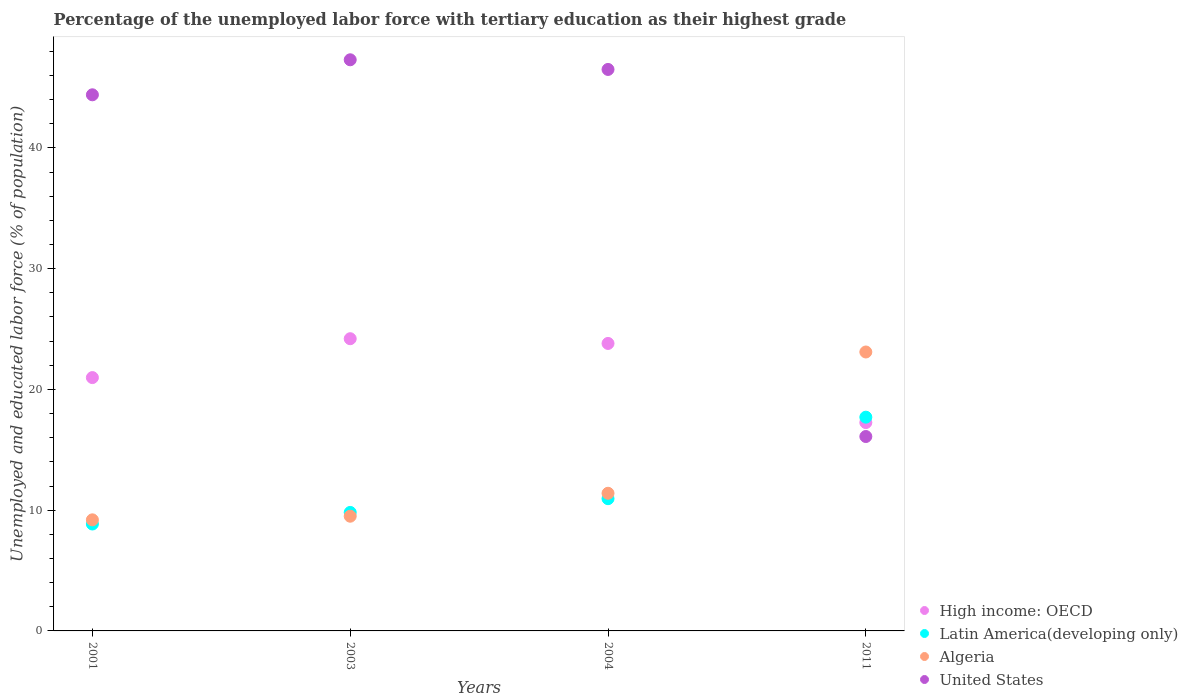How many different coloured dotlines are there?
Your answer should be compact. 4. Is the number of dotlines equal to the number of legend labels?
Offer a very short reply. Yes. Across all years, what is the maximum percentage of the unemployed labor force with tertiary education in Latin America(developing only)?
Provide a succinct answer. 17.7. Across all years, what is the minimum percentage of the unemployed labor force with tertiary education in Latin America(developing only)?
Offer a very short reply. 8.85. In which year was the percentage of the unemployed labor force with tertiary education in United States maximum?
Your response must be concise. 2003. In which year was the percentage of the unemployed labor force with tertiary education in Latin America(developing only) minimum?
Offer a terse response. 2001. What is the total percentage of the unemployed labor force with tertiary education in Latin America(developing only) in the graph?
Offer a terse response. 47.32. What is the difference between the percentage of the unemployed labor force with tertiary education in Latin America(developing only) in 2003 and that in 2004?
Your answer should be compact. -1.14. What is the difference between the percentage of the unemployed labor force with tertiary education in High income: OECD in 2003 and the percentage of the unemployed labor force with tertiary education in United States in 2001?
Your answer should be compact. -20.2. What is the average percentage of the unemployed labor force with tertiary education in Latin America(developing only) per year?
Your answer should be very brief. 11.83. In the year 2003, what is the difference between the percentage of the unemployed labor force with tertiary education in United States and percentage of the unemployed labor force with tertiary education in Latin America(developing only)?
Make the answer very short. 37.49. In how many years, is the percentage of the unemployed labor force with tertiary education in Algeria greater than 4 %?
Keep it short and to the point. 4. What is the ratio of the percentage of the unemployed labor force with tertiary education in United States in 2003 to that in 2004?
Give a very brief answer. 1.02. Is the percentage of the unemployed labor force with tertiary education in High income: OECD in 2001 less than that in 2011?
Offer a terse response. No. Is the difference between the percentage of the unemployed labor force with tertiary education in United States in 2001 and 2003 greater than the difference between the percentage of the unemployed labor force with tertiary education in Latin America(developing only) in 2001 and 2003?
Give a very brief answer. No. What is the difference between the highest and the second highest percentage of the unemployed labor force with tertiary education in United States?
Your response must be concise. 0.8. What is the difference between the highest and the lowest percentage of the unemployed labor force with tertiary education in Algeria?
Ensure brevity in your answer.  13.9. Is the sum of the percentage of the unemployed labor force with tertiary education in Algeria in 2004 and 2011 greater than the maximum percentage of the unemployed labor force with tertiary education in United States across all years?
Your response must be concise. No. Does the percentage of the unemployed labor force with tertiary education in High income: OECD monotonically increase over the years?
Provide a short and direct response. No. How many dotlines are there?
Your answer should be very brief. 4. What is the difference between two consecutive major ticks on the Y-axis?
Your answer should be compact. 10. Does the graph contain grids?
Make the answer very short. No. Where does the legend appear in the graph?
Make the answer very short. Bottom right. What is the title of the graph?
Give a very brief answer. Percentage of the unemployed labor force with tertiary education as their highest grade. Does "Tajikistan" appear as one of the legend labels in the graph?
Make the answer very short. No. What is the label or title of the Y-axis?
Offer a very short reply. Unemployed and educated labor force (% of population). What is the Unemployed and educated labor force (% of population) in High income: OECD in 2001?
Offer a very short reply. 20.98. What is the Unemployed and educated labor force (% of population) in Latin America(developing only) in 2001?
Provide a succinct answer. 8.85. What is the Unemployed and educated labor force (% of population) of Algeria in 2001?
Your answer should be compact. 9.2. What is the Unemployed and educated labor force (% of population) in United States in 2001?
Offer a terse response. 44.4. What is the Unemployed and educated labor force (% of population) of High income: OECD in 2003?
Make the answer very short. 24.2. What is the Unemployed and educated labor force (% of population) of Latin America(developing only) in 2003?
Offer a terse response. 9.81. What is the Unemployed and educated labor force (% of population) of Algeria in 2003?
Provide a succinct answer. 9.5. What is the Unemployed and educated labor force (% of population) in United States in 2003?
Your answer should be very brief. 47.3. What is the Unemployed and educated labor force (% of population) in High income: OECD in 2004?
Provide a short and direct response. 23.81. What is the Unemployed and educated labor force (% of population) in Latin America(developing only) in 2004?
Keep it short and to the point. 10.95. What is the Unemployed and educated labor force (% of population) in Algeria in 2004?
Offer a terse response. 11.4. What is the Unemployed and educated labor force (% of population) in United States in 2004?
Keep it short and to the point. 46.5. What is the Unemployed and educated labor force (% of population) of High income: OECD in 2011?
Your answer should be very brief. 17.26. What is the Unemployed and educated labor force (% of population) in Latin America(developing only) in 2011?
Provide a succinct answer. 17.7. What is the Unemployed and educated labor force (% of population) of Algeria in 2011?
Provide a short and direct response. 23.1. What is the Unemployed and educated labor force (% of population) of United States in 2011?
Your answer should be very brief. 16.1. Across all years, what is the maximum Unemployed and educated labor force (% of population) in High income: OECD?
Offer a terse response. 24.2. Across all years, what is the maximum Unemployed and educated labor force (% of population) in Latin America(developing only)?
Your response must be concise. 17.7. Across all years, what is the maximum Unemployed and educated labor force (% of population) in Algeria?
Offer a terse response. 23.1. Across all years, what is the maximum Unemployed and educated labor force (% of population) of United States?
Ensure brevity in your answer.  47.3. Across all years, what is the minimum Unemployed and educated labor force (% of population) of High income: OECD?
Provide a succinct answer. 17.26. Across all years, what is the minimum Unemployed and educated labor force (% of population) in Latin America(developing only)?
Provide a succinct answer. 8.85. Across all years, what is the minimum Unemployed and educated labor force (% of population) in Algeria?
Ensure brevity in your answer.  9.2. Across all years, what is the minimum Unemployed and educated labor force (% of population) in United States?
Provide a succinct answer. 16.1. What is the total Unemployed and educated labor force (% of population) in High income: OECD in the graph?
Your answer should be very brief. 86.24. What is the total Unemployed and educated labor force (% of population) in Latin America(developing only) in the graph?
Keep it short and to the point. 47.32. What is the total Unemployed and educated labor force (% of population) in Algeria in the graph?
Give a very brief answer. 53.2. What is the total Unemployed and educated labor force (% of population) of United States in the graph?
Provide a succinct answer. 154.3. What is the difference between the Unemployed and educated labor force (% of population) of High income: OECD in 2001 and that in 2003?
Provide a succinct answer. -3.22. What is the difference between the Unemployed and educated labor force (% of population) of Latin America(developing only) in 2001 and that in 2003?
Give a very brief answer. -0.96. What is the difference between the Unemployed and educated labor force (% of population) of Algeria in 2001 and that in 2003?
Your answer should be very brief. -0.3. What is the difference between the Unemployed and educated labor force (% of population) of High income: OECD in 2001 and that in 2004?
Provide a short and direct response. -2.83. What is the difference between the Unemployed and educated labor force (% of population) in Latin America(developing only) in 2001 and that in 2004?
Keep it short and to the point. -2.1. What is the difference between the Unemployed and educated labor force (% of population) in Algeria in 2001 and that in 2004?
Make the answer very short. -2.2. What is the difference between the Unemployed and educated labor force (% of population) of United States in 2001 and that in 2004?
Offer a very short reply. -2.1. What is the difference between the Unemployed and educated labor force (% of population) in High income: OECD in 2001 and that in 2011?
Ensure brevity in your answer.  3.72. What is the difference between the Unemployed and educated labor force (% of population) of Latin America(developing only) in 2001 and that in 2011?
Provide a succinct answer. -8.85. What is the difference between the Unemployed and educated labor force (% of population) in United States in 2001 and that in 2011?
Your response must be concise. 28.3. What is the difference between the Unemployed and educated labor force (% of population) in High income: OECD in 2003 and that in 2004?
Your answer should be very brief. 0.39. What is the difference between the Unemployed and educated labor force (% of population) of Latin America(developing only) in 2003 and that in 2004?
Your answer should be very brief. -1.14. What is the difference between the Unemployed and educated labor force (% of population) of Algeria in 2003 and that in 2004?
Your answer should be compact. -1.9. What is the difference between the Unemployed and educated labor force (% of population) in High income: OECD in 2003 and that in 2011?
Provide a short and direct response. 6.94. What is the difference between the Unemployed and educated labor force (% of population) of Latin America(developing only) in 2003 and that in 2011?
Your response must be concise. -7.89. What is the difference between the Unemployed and educated labor force (% of population) in Algeria in 2003 and that in 2011?
Offer a terse response. -13.6. What is the difference between the Unemployed and educated labor force (% of population) of United States in 2003 and that in 2011?
Your answer should be compact. 31.2. What is the difference between the Unemployed and educated labor force (% of population) in High income: OECD in 2004 and that in 2011?
Ensure brevity in your answer.  6.55. What is the difference between the Unemployed and educated labor force (% of population) of Latin America(developing only) in 2004 and that in 2011?
Your answer should be very brief. -6.75. What is the difference between the Unemployed and educated labor force (% of population) in Algeria in 2004 and that in 2011?
Your response must be concise. -11.7. What is the difference between the Unemployed and educated labor force (% of population) in United States in 2004 and that in 2011?
Provide a short and direct response. 30.4. What is the difference between the Unemployed and educated labor force (% of population) of High income: OECD in 2001 and the Unemployed and educated labor force (% of population) of Latin America(developing only) in 2003?
Offer a terse response. 11.17. What is the difference between the Unemployed and educated labor force (% of population) in High income: OECD in 2001 and the Unemployed and educated labor force (% of population) in Algeria in 2003?
Provide a succinct answer. 11.48. What is the difference between the Unemployed and educated labor force (% of population) in High income: OECD in 2001 and the Unemployed and educated labor force (% of population) in United States in 2003?
Ensure brevity in your answer.  -26.32. What is the difference between the Unemployed and educated labor force (% of population) in Latin America(developing only) in 2001 and the Unemployed and educated labor force (% of population) in Algeria in 2003?
Your answer should be compact. -0.65. What is the difference between the Unemployed and educated labor force (% of population) of Latin America(developing only) in 2001 and the Unemployed and educated labor force (% of population) of United States in 2003?
Give a very brief answer. -38.45. What is the difference between the Unemployed and educated labor force (% of population) in Algeria in 2001 and the Unemployed and educated labor force (% of population) in United States in 2003?
Offer a very short reply. -38.1. What is the difference between the Unemployed and educated labor force (% of population) in High income: OECD in 2001 and the Unemployed and educated labor force (% of population) in Latin America(developing only) in 2004?
Provide a succinct answer. 10.03. What is the difference between the Unemployed and educated labor force (% of population) in High income: OECD in 2001 and the Unemployed and educated labor force (% of population) in Algeria in 2004?
Offer a terse response. 9.58. What is the difference between the Unemployed and educated labor force (% of population) of High income: OECD in 2001 and the Unemployed and educated labor force (% of population) of United States in 2004?
Provide a short and direct response. -25.52. What is the difference between the Unemployed and educated labor force (% of population) in Latin America(developing only) in 2001 and the Unemployed and educated labor force (% of population) in Algeria in 2004?
Ensure brevity in your answer.  -2.55. What is the difference between the Unemployed and educated labor force (% of population) of Latin America(developing only) in 2001 and the Unemployed and educated labor force (% of population) of United States in 2004?
Make the answer very short. -37.65. What is the difference between the Unemployed and educated labor force (% of population) in Algeria in 2001 and the Unemployed and educated labor force (% of population) in United States in 2004?
Your answer should be compact. -37.3. What is the difference between the Unemployed and educated labor force (% of population) in High income: OECD in 2001 and the Unemployed and educated labor force (% of population) in Latin America(developing only) in 2011?
Your answer should be very brief. 3.28. What is the difference between the Unemployed and educated labor force (% of population) of High income: OECD in 2001 and the Unemployed and educated labor force (% of population) of Algeria in 2011?
Make the answer very short. -2.12. What is the difference between the Unemployed and educated labor force (% of population) in High income: OECD in 2001 and the Unemployed and educated labor force (% of population) in United States in 2011?
Make the answer very short. 4.88. What is the difference between the Unemployed and educated labor force (% of population) of Latin America(developing only) in 2001 and the Unemployed and educated labor force (% of population) of Algeria in 2011?
Provide a short and direct response. -14.25. What is the difference between the Unemployed and educated labor force (% of population) of Latin America(developing only) in 2001 and the Unemployed and educated labor force (% of population) of United States in 2011?
Ensure brevity in your answer.  -7.25. What is the difference between the Unemployed and educated labor force (% of population) of High income: OECD in 2003 and the Unemployed and educated labor force (% of population) of Latin America(developing only) in 2004?
Ensure brevity in your answer.  13.25. What is the difference between the Unemployed and educated labor force (% of population) in High income: OECD in 2003 and the Unemployed and educated labor force (% of population) in Algeria in 2004?
Offer a very short reply. 12.8. What is the difference between the Unemployed and educated labor force (% of population) in High income: OECD in 2003 and the Unemployed and educated labor force (% of population) in United States in 2004?
Your answer should be compact. -22.3. What is the difference between the Unemployed and educated labor force (% of population) in Latin America(developing only) in 2003 and the Unemployed and educated labor force (% of population) in Algeria in 2004?
Provide a short and direct response. -1.59. What is the difference between the Unemployed and educated labor force (% of population) of Latin America(developing only) in 2003 and the Unemployed and educated labor force (% of population) of United States in 2004?
Ensure brevity in your answer.  -36.69. What is the difference between the Unemployed and educated labor force (% of population) of Algeria in 2003 and the Unemployed and educated labor force (% of population) of United States in 2004?
Your answer should be compact. -37. What is the difference between the Unemployed and educated labor force (% of population) of High income: OECD in 2003 and the Unemployed and educated labor force (% of population) of Latin America(developing only) in 2011?
Give a very brief answer. 6.5. What is the difference between the Unemployed and educated labor force (% of population) of High income: OECD in 2003 and the Unemployed and educated labor force (% of population) of United States in 2011?
Your answer should be very brief. 8.1. What is the difference between the Unemployed and educated labor force (% of population) in Latin America(developing only) in 2003 and the Unemployed and educated labor force (% of population) in Algeria in 2011?
Your response must be concise. -13.29. What is the difference between the Unemployed and educated labor force (% of population) in Latin America(developing only) in 2003 and the Unemployed and educated labor force (% of population) in United States in 2011?
Provide a short and direct response. -6.29. What is the difference between the Unemployed and educated labor force (% of population) of High income: OECD in 2004 and the Unemployed and educated labor force (% of population) of Latin America(developing only) in 2011?
Keep it short and to the point. 6.11. What is the difference between the Unemployed and educated labor force (% of population) of High income: OECD in 2004 and the Unemployed and educated labor force (% of population) of Algeria in 2011?
Your answer should be very brief. 0.71. What is the difference between the Unemployed and educated labor force (% of population) of High income: OECD in 2004 and the Unemployed and educated labor force (% of population) of United States in 2011?
Provide a succinct answer. 7.71. What is the difference between the Unemployed and educated labor force (% of population) in Latin America(developing only) in 2004 and the Unemployed and educated labor force (% of population) in Algeria in 2011?
Your response must be concise. -12.15. What is the difference between the Unemployed and educated labor force (% of population) of Latin America(developing only) in 2004 and the Unemployed and educated labor force (% of population) of United States in 2011?
Your answer should be compact. -5.15. What is the average Unemployed and educated labor force (% of population) in High income: OECD per year?
Your response must be concise. 21.56. What is the average Unemployed and educated labor force (% of population) in Latin America(developing only) per year?
Your answer should be very brief. 11.83. What is the average Unemployed and educated labor force (% of population) in United States per year?
Keep it short and to the point. 38.58. In the year 2001, what is the difference between the Unemployed and educated labor force (% of population) of High income: OECD and Unemployed and educated labor force (% of population) of Latin America(developing only)?
Offer a very short reply. 12.13. In the year 2001, what is the difference between the Unemployed and educated labor force (% of population) of High income: OECD and Unemployed and educated labor force (% of population) of Algeria?
Keep it short and to the point. 11.78. In the year 2001, what is the difference between the Unemployed and educated labor force (% of population) in High income: OECD and Unemployed and educated labor force (% of population) in United States?
Make the answer very short. -23.42. In the year 2001, what is the difference between the Unemployed and educated labor force (% of population) in Latin America(developing only) and Unemployed and educated labor force (% of population) in Algeria?
Make the answer very short. -0.35. In the year 2001, what is the difference between the Unemployed and educated labor force (% of population) in Latin America(developing only) and Unemployed and educated labor force (% of population) in United States?
Provide a succinct answer. -35.55. In the year 2001, what is the difference between the Unemployed and educated labor force (% of population) in Algeria and Unemployed and educated labor force (% of population) in United States?
Your answer should be compact. -35.2. In the year 2003, what is the difference between the Unemployed and educated labor force (% of population) in High income: OECD and Unemployed and educated labor force (% of population) in Latin America(developing only)?
Your answer should be very brief. 14.39. In the year 2003, what is the difference between the Unemployed and educated labor force (% of population) of High income: OECD and Unemployed and educated labor force (% of population) of Algeria?
Make the answer very short. 14.7. In the year 2003, what is the difference between the Unemployed and educated labor force (% of population) of High income: OECD and Unemployed and educated labor force (% of population) of United States?
Give a very brief answer. -23.1. In the year 2003, what is the difference between the Unemployed and educated labor force (% of population) in Latin America(developing only) and Unemployed and educated labor force (% of population) in Algeria?
Provide a short and direct response. 0.31. In the year 2003, what is the difference between the Unemployed and educated labor force (% of population) in Latin America(developing only) and Unemployed and educated labor force (% of population) in United States?
Provide a short and direct response. -37.49. In the year 2003, what is the difference between the Unemployed and educated labor force (% of population) in Algeria and Unemployed and educated labor force (% of population) in United States?
Offer a very short reply. -37.8. In the year 2004, what is the difference between the Unemployed and educated labor force (% of population) in High income: OECD and Unemployed and educated labor force (% of population) in Latin America(developing only)?
Provide a succinct answer. 12.86. In the year 2004, what is the difference between the Unemployed and educated labor force (% of population) in High income: OECD and Unemployed and educated labor force (% of population) in Algeria?
Give a very brief answer. 12.41. In the year 2004, what is the difference between the Unemployed and educated labor force (% of population) of High income: OECD and Unemployed and educated labor force (% of population) of United States?
Provide a short and direct response. -22.69. In the year 2004, what is the difference between the Unemployed and educated labor force (% of population) in Latin America(developing only) and Unemployed and educated labor force (% of population) in Algeria?
Your response must be concise. -0.45. In the year 2004, what is the difference between the Unemployed and educated labor force (% of population) in Latin America(developing only) and Unemployed and educated labor force (% of population) in United States?
Make the answer very short. -35.55. In the year 2004, what is the difference between the Unemployed and educated labor force (% of population) of Algeria and Unemployed and educated labor force (% of population) of United States?
Keep it short and to the point. -35.1. In the year 2011, what is the difference between the Unemployed and educated labor force (% of population) in High income: OECD and Unemployed and educated labor force (% of population) in Latin America(developing only)?
Offer a terse response. -0.45. In the year 2011, what is the difference between the Unemployed and educated labor force (% of population) in High income: OECD and Unemployed and educated labor force (% of population) in Algeria?
Ensure brevity in your answer.  -5.84. In the year 2011, what is the difference between the Unemployed and educated labor force (% of population) of High income: OECD and Unemployed and educated labor force (% of population) of United States?
Your response must be concise. 1.16. In the year 2011, what is the difference between the Unemployed and educated labor force (% of population) of Latin America(developing only) and Unemployed and educated labor force (% of population) of Algeria?
Give a very brief answer. -5.4. In the year 2011, what is the difference between the Unemployed and educated labor force (% of population) of Latin America(developing only) and Unemployed and educated labor force (% of population) of United States?
Ensure brevity in your answer.  1.6. In the year 2011, what is the difference between the Unemployed and educated labor force (% of population) in Algeria and Unemployed and educated labor force (% of population) in United States?
Ensure brevity in your answer.  7. What is the ratio of the Unemployed and educated labor force (% of population) of High income: OECD in 2001 to that in 2003?
Keep it short and to the point. 0.87. What is the ratio of the Unemployed and educated labor force (% of population) of Latin America(developing only) in 2001 to that in 2003?
Provide a succinct answer. 0.9. What is the ratio of the Unemployed and educated labor force (% of population) of Algeria in 2001 to that in 2003?
Ensure brevity in your answer.  0.97. What is the ratio of the Unemployed and educated labor force (% of population) of United States in 2001 to that in 2003?
Your answer should be compact. 0.94. What is the ratio of the Unemployed and educated labor force (% of population) of High income: OECD in 2001 to that in 2004?
Make the answer very short. 0.88. What is the ratio of the Unemployed and educated labor force (% of population) of Latin America(developing only) in 2001 to that in 2004?
Offer a terse response. 0.81. What is the ratio of the Unemployed and educated labor force (% of population) in Algeria in 2001 to that in 2004?
Your answer should be compact. 0.81. What is the ratio of the Unemployed and educated labor force (% of population) of United States in 2001 to that in 2004?
Give a very brief answer. 0.95. What is the ratio of the Unemployed and educated labor force (% of population) of High income: OECD in 2001 to that in 2011?
Provide a succinct answer. 1.22. What is the ratio of the Unemployed and educated labor force (% of population) of Latin America(developing only) in 2001 to that in 2011?
Offer a terse response. 0.5. What is the ratio of the Unemployed and educated labor force (% of population) in Algeria in 2001 to that in 2011?
Keep it short and to the point. 0.4. What is the ratio of the Unemployed and educated labor force (% of population) of United States in 2001 to that in 2011?
Ensure brevity in your answer.  2.76. What is the ratio of the Unemployed and educated labor force (% of population) of High income: OECD in 2003 to that in 2004?
Ensure brevity in your answer.  1.02. What is the ratio of the Unemployed and educated labor force (% of population) in Latin America(developing only) in 2003 to that in 2004?
Your response must be concise. 0.9. What is the ratio of the Unemployed and educated labor force (% of population) in United States in 2003 to that in 2004?
Give a very brief answer. 1.02. What is the ratio of the Unemployed and educated labor force (% of population) of High income: OECD in 2003 to that in 2011?
Make the answer very short. 1.4. What is the ratio of the Unemployed and educated labor force (% of population) of Latin America(developing only) in 2003 to that in 2011?
Your response must be concise. 0.55. What is the ratio of the Unemployed and educated labor force (% of population) of Algeria in 2003 to that in 2011?
Make the answer very short. 0.41. What is the ratio of the Unemployed and educated labor force (% of population) of United States in 2003 to that in 2011?
Offer a very short reply. 2.94. What is the ratio of the Unemployed and educated labor force (% of population) of High income: OECD in 2004 to that in 2011?
Provide a succinct answer. 1.38. What is the ratio of the Unemployed and educated labor force (% of population) in Latin America(developing only) in 2004 to that in 2011?
Offer a terse response. 0.62. What is the ratio of the Unemployed and educated labor force (% of population) of Algeria in 2004 to that in 2011?
Give a very brief answer. 0.49. What is the ratio of the Unemployed and educated labor force (% of population) in United States in 2004 to that in 2011?
Your response must be concise. 2.89. What is the difference between the highest and the second highest Unemployed and educated labor force (% of population) of High income: OECD?
Offer a terse response. 0.39. What is the difference between the highest and the second highest Unemployed and educated labor force (% of population) of Latin America(developing only)?
Offer a terse response. 6.75. What is the difference between the highest and the second highest Unemployed and educated labor force (% of population) of Algeria?
Your response must be concise. 11.7. What is the difference between the highest and the second highest Unemployed and educated labor force (% of population) in United States?
Provide a succinct answer. 0.8. What is the difference between the highest and the lowest Unemployed and educated labor force (% of population) of High income: OECD?
Make the answer very short. 6.94. What is the difference between the highest and the lowest Unemployed and educated labor force (% of population) of Latin America(developing only)?
Give a very brief answer. 8.85. What is the difference between the highest and the lowest Unemployed and educated labor force (% of population) of Algeria?
Give a very brief answer. 13.9. What is the difference between the highest and the lowest Unemployed and educated labor force (% of population) of United States?
Keep it short and to the point. 31.2. 